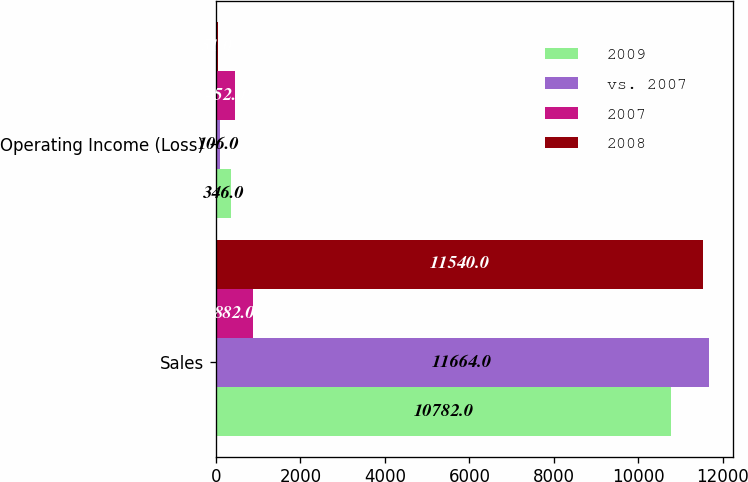Convert chart to OTSL. <chart><loc_0><loc_0><loc_500><loc_500><stacked_bar_chart><ecel><fcel>Sales<fcel>Operating Income (Loss)<nl><fcel>2009<fcel>10782<fcel>346<nl><fcel>vs. 2007<fcel>11664<fcel>106<nl><fcel>2007<fcel>882<fcel>452<nl><fcel>2008<fcel>11540<fcel>51<nl></chart> 